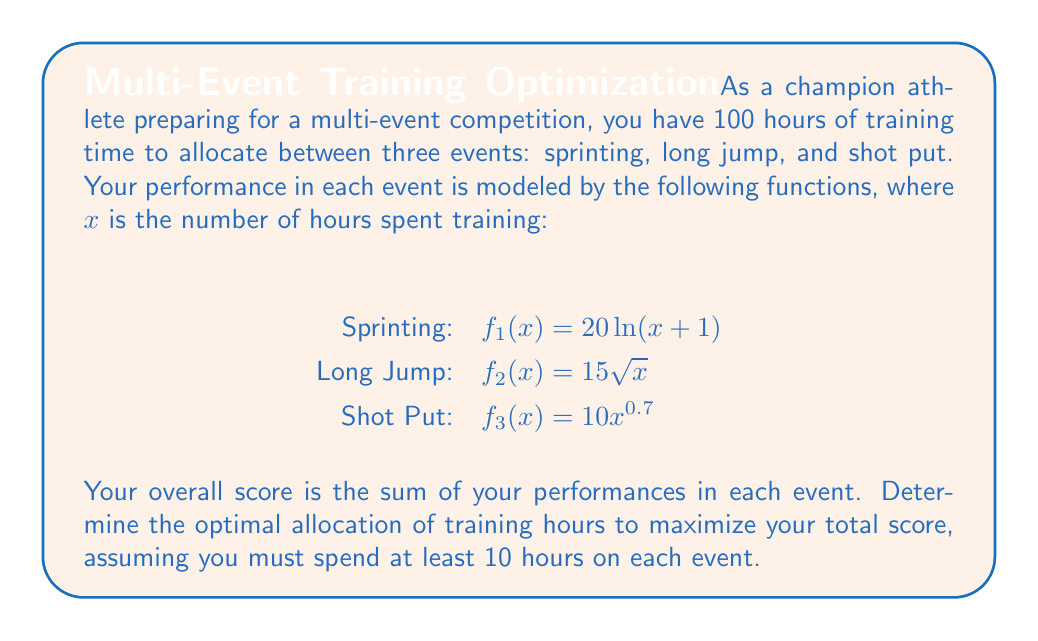Teach me how to tackle this problem. To solve this optimization problem, we'll use the method of Lagrange multipliers with inequality constraints. Let's approach this step-by-step:

1) Let $x$, $y$, and $z$ be the hours spent on sprinting, long jump, and shot put respectively.

2) Our objective function is:
   $F(x,y,z) = 20\ln(x+1) + 15\sqrt{y} + 10z^{0.7}$

3) Our constraints are:
   $g(x,y,z) = x + y + z - 100 = 0$
   $x \geq 10$, $y \geq 10$, $z \geq 10$

4) We form the Lagrangian:
   $L(x,y,z,\lambda) = 20\ln(x+1) + 15\sqrt{y} + 10z^{0.7} - \lambda(x + y + z - 100)$

5) The KKT conditions give us:
   $\frac{\partial L}{\partial x} = \frac{20}{x+1} - \lambda = 0$
   $\frac{\partial L}{\partial y} = \frac{15}{2\sqrt{y}} - \lambda = 0$
   $\frac{\partial L}{\partial z} = 7z^{-0.3} - \lambda = 0$
   $x + y + z = 100$

6) From these equations, we can derive:
   $x = \frac{20}{\lambda} - 1$
   $y = (\frac{15}{2\lambda})^2$
   $z = (\frac{7}{\lambda})^{\frac{10}{3}}$

7) Substituting these into the constraint equation:
   $\frac{20}{\lambda} - 1 + (\frac{15}{2\lambda})^2 + (\frac{7}{\lambda})^{\frac{10}{3}} = 100$

8) This equation can be solved numerically to find $\lambda \approx 0.2968$

9) Substituting this value back, we get:
   $x \approx 66.37$, $y \approx 25.42$, $z \approx 8.21$

10) However, $z < 10$, violating our constraint. This means the optimal solution lies on the boundary where $z = 10$.

11) We now solve:
    $20\ln(x+1) + 15\sqrt{y} + 10(10)^{0.7}$
    subject to $x + y = 90$ and $x,y \geq 10$

12) Following a similar process, we find:
    $x \approx 65.14$, $y \approx 24.86$

Therefore, the optimal allocation is approximately 65 hours for sprinting, 25 hours for long jump, and 10 hours for shot put.
Answer: The optimal allocation of training hours is approximately:
Sprinting: 65 hours
Long Jump: 25 hours
Shot Put: 10 hours 